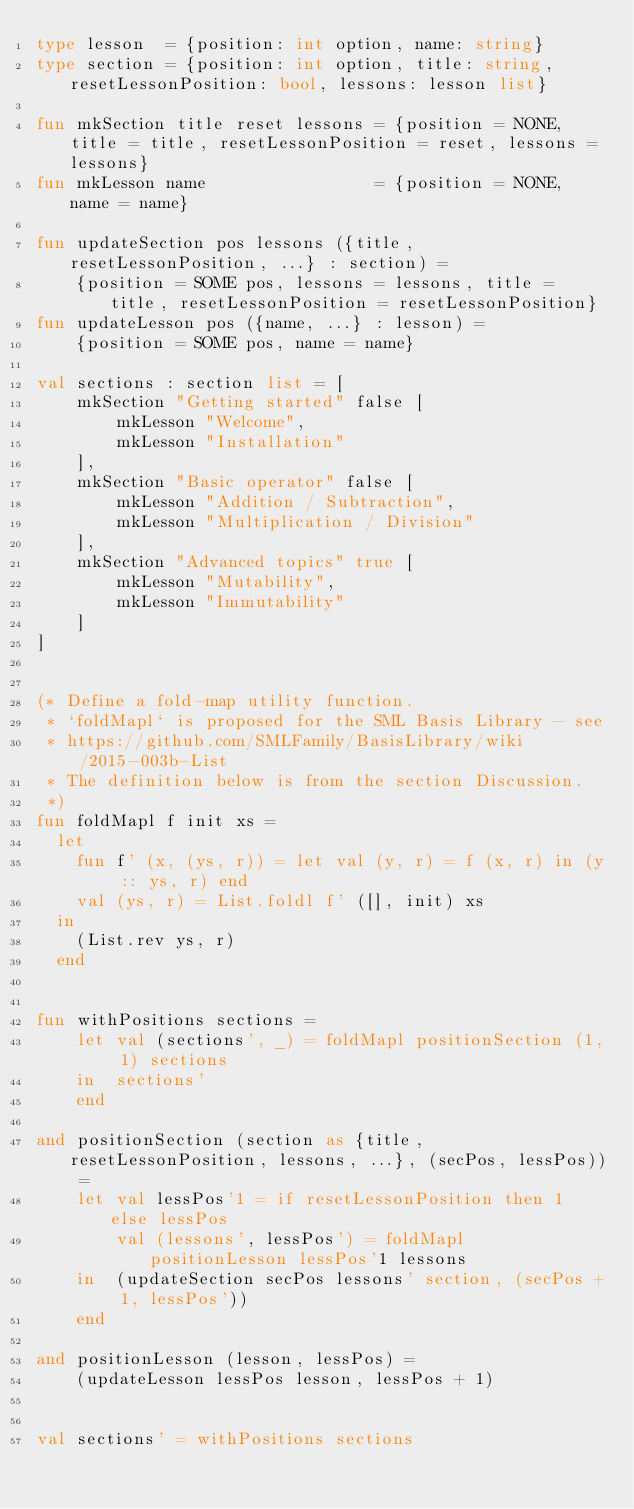Convert code to text. <code><loc_0><loc_0><loc_500><loc_500><_SML_>type lesson  = {position: int option, name: string}
type section = {position: int option, title: string, resetLessonPosition: bool, lessons: lesson list}

fun mkSection title reset lessons = {position = NONE, title = title, resetLessonPosition = reset, lessons = lessons}
fun mkLesson name                 = {position = NONE, name = name}

fun updateSection pos lessons ({title, resetLessonPosition, ...} : section) =
    {position = SOME pos, lessons = lessons, title = title, resetLessonPosition = resetLessonPosition}
fun updateLesson pos ({name, ...} : lesson) =
    {position = SOME pos, name = name}

val sections : section list = [
    mkSection "Getting started" false [
        mkLesson "Welcome",
        mkLesson "Installation"
    ],
    mkSection "Basic operator" false [
        mkLesson "Addition / Subtraction",
        mkLesson "Multiplication / Division"
    ],
    mkSection "Advanced topics" true [
        mkLesson "Mutability",
        mkLesson "Immutability"
    ]
]


(* Define a fold-map utility function.
 * `foldMapl` is proposed for the SML Basis Library - see
 * https://github.com/SMLFamily/BasisLibrary/wiki/2015-003b-List
 * The definition below is from the section Discussion.
 *)
fun foldMapl f init xs =
  let
    fun f' (x, (ys, r)) = let val (y, r) = f (x, r) in (y :: ys, r) end
    val (ys, r) = List.foldl f' ([], init) xs
  in
    (List.rev ys, r)
  end


fun withPositions sections =
    let val (sections', _) = foldMapl positionSection (1, 1) sections
    in  sections'
    end

and positionSection (section as {title, resetLessonPosition, lessons, ...}, (secPos, lessPos)) =
    let val lessPos'1 = if resetLessonPosition then 1 else lessPos
        val (lessons', lessPos') = foldMapl positionLesson lessPos'1 lessons
    in  (updateSection secPos lessons' section, (secPos + 1, lessPos'))
    end

and positionLesson (lesson, lessPos) =
    (updateLesson lessPos lesson, lessPos + 1)


val sections' = withPositions sections
</code> 